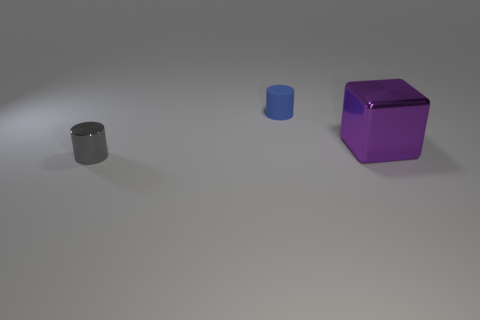Add 3 tiny gray metal cylinders. How many objects exist? 6 Subtract all blocks. How many objects are left? 2 Subtract 1 gray cylinders. How many objects are left? 2 Subtract all yellow shiny spheres. Subtract all purple blocks. How many objects are left? 2 Add 3 tiny gray metal objects. How many tiny gray metal objects are left? 4 Add 3 small matte objects. How many small matte objects exist? 4 